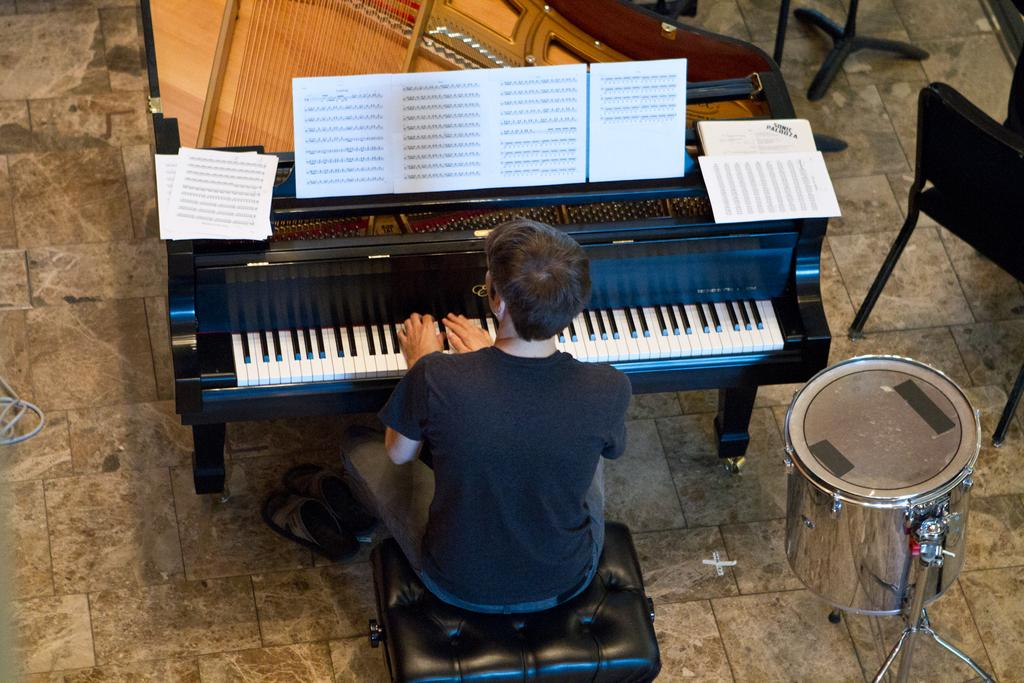What is the man in the image doing? The man is sitting in a chair and playing the piano. What else is the man doing while playing the piano? The man is also reading a book while playing the piano. What can be seen in the background of the image? There are drums and chairs in the background of the image. How many things can be seen in the man's grip while playing the piano? The man is not holding any objects in his grip while playing the piano, so it is not possible to determine the number of things he is gripping. 